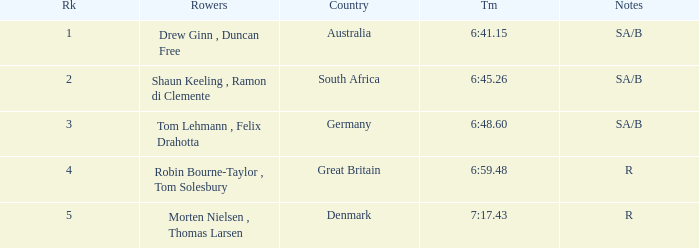What was the time for the rowers representing great britain? 6:59.48. 